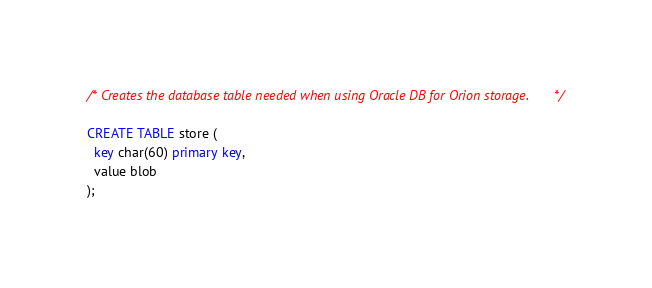Convert code to text. <code><loc_0><loc_0><loc_500><loc_500><_SQL_>/* Creates the database table needed when using Oracle DB for Orion storage. */

CREATE TABLE store (
  key char(60) primary key,
  value blob
);</code> 